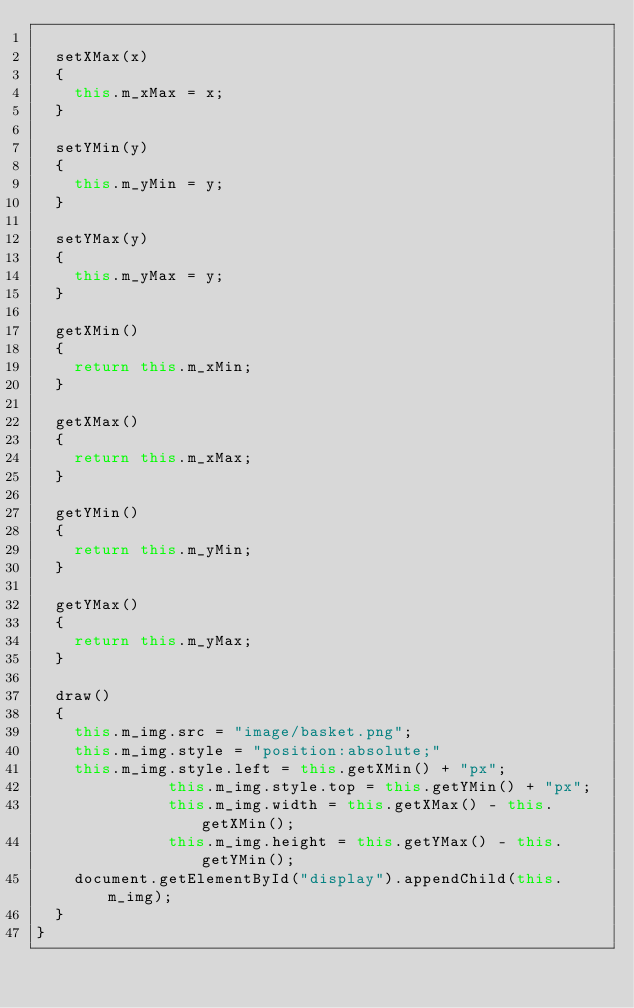Convert code to text. <code><loc_0><loc_0><loc_500><loc_500><_JavaScript_>
	setXMax(x)
	{
		this.m_xMax = x;
	}

	setYMin(y)
	{
		this.m_yMin = y;
	}

	setYMax(y)
	{
		this.m_yMax = y;
	}

	getXMin()
	{
		return this.m_xMin;
	}

	getXMax()
	{
		return this.m_xMax;
	}

	getYMin()
	{
		return this.m_yMin;
	}

	getYMax()
	{
		return this.m_yMax;
	}

	draw()
	{
		this.m_img.src = "image/basket.png";
		this.m_img.style = "position:absolute;"
		this.m_img.style.left = this.getXMin() + "px";
    	        this.m_img.style.top = this.getYMin() + "px";
    	        this.m_img.width = this.getXMax() - this.getXMin();
    	        this.m_img.height = this.getYMax() - this.getYMin();
		document.getElementById("display").appendChild(this.m_img);
	}
}
</code> 